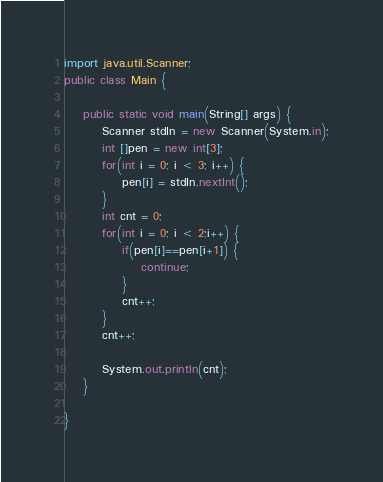Convert code to text. <code><loc_0><loc_0><loc_500><loc_500><_Java_>import java.util.Scanner;
public class Main {

	public static void main(String[] args) {
		Scanner stdIn = new Scanner(System.in);
		int []pen = new int[3];
		for(int i = 0; i < 3; i++) {
			pen[i] = stdIn.nextInt();
		}
		int cnt = 0;
		for(int i = 0; i < 2;i++) {
			if(pen[i]==pen[i+1]) {
				continue;
			}
			cnt++;
		}
		cnt++;
		
		System.out.println(cnt);
	}

}
</code> 